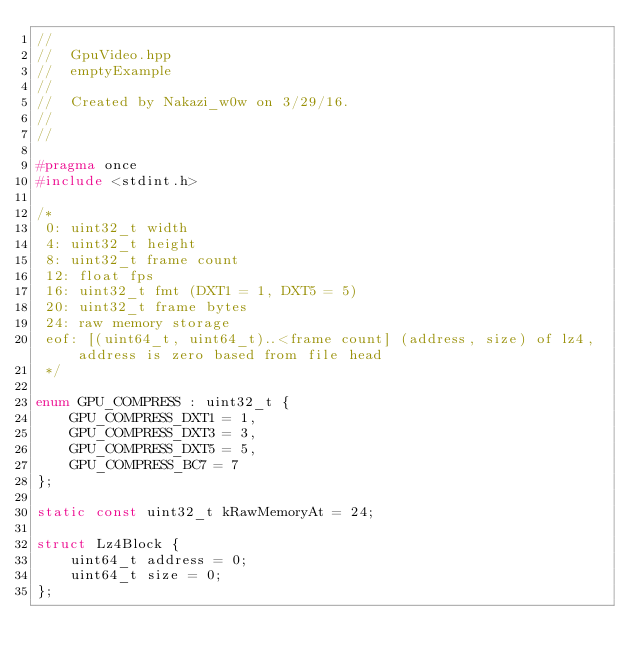Convert code to text. <code><loc_0><loc_0><loc_500><loc_500><_C_>//
//  GpuVideo.hpp
//  emptyExample
//
//  Created by Nakazi_w0w on 3/29/16.
//
//

#pragma once
#include <stdint.h>

/*
 0: uint32_t width
 4: uint32_t height
 8: uint32_t frame count
 12: float fps
 16: uint32_t fmt (DXT1 = 1, DXT5 = 5)
 20: uint32_t frame bytes
 24: raw memory storage
 eof: [(uint64_t, uint64_t)..<frame count] (address, size) of lz4, address is zero based from file head
 */

enum GPU_COMPRESS : uint32_t {
    GPU_COMPRESS_DXT1 = 1,
    GPU_COMPRESS_DXT3 = 3,
    GPU_COMPRESS_DXT5 = 5,
    GPU_COMPRESS_BC7 = 7
};

static const uint32_t kRawMemoryAt = 24;

struct Lz4Block {
    uint64_t address = 0;
    uint64_t size = 0;
};</code> 